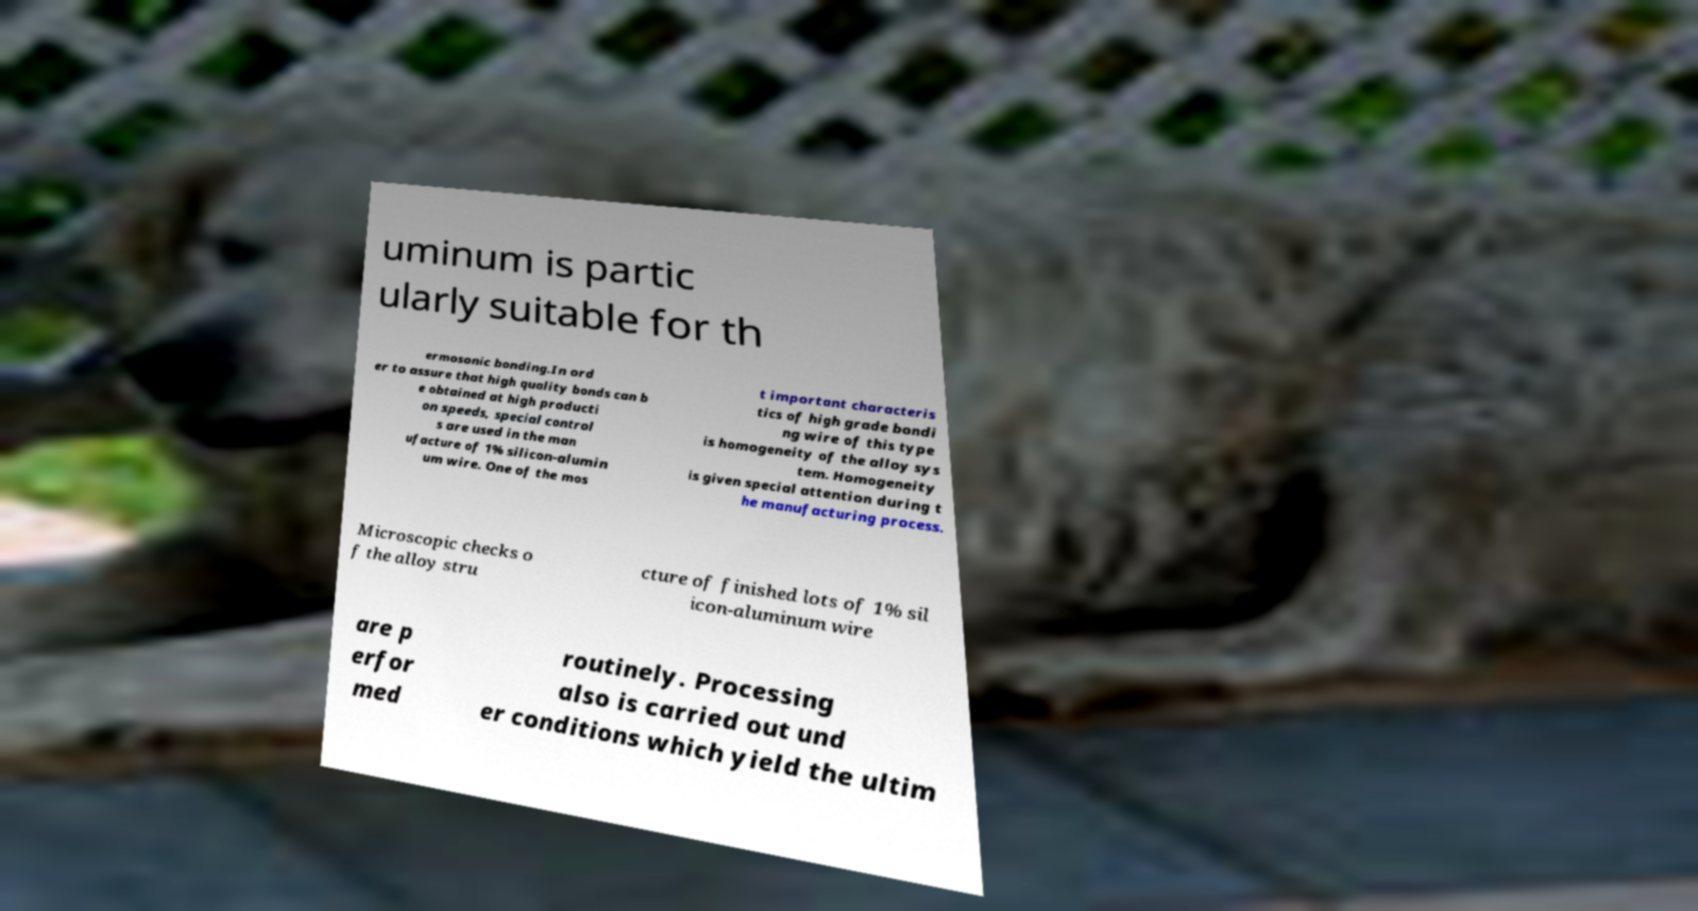What messages or text are displayed in this image? I need them in a readable, typed format. uminum is partic ularly suitable for th ermosonic bonding.In ord er to assure that high quality bonds can b e obtained at high producti on speeds, special control s are used in the man ufacture of 1% silicon-alumin um wire. One of the mos t important characteris tics of high grade bondi ng wire of this type is homogeneity of the alloy sys tem. Homogeneity is given special attention during t he manufacturing process. Microscopic checks o f the alloy stru cture of finished lots of 1% sil icon-aluminum wire are p erfor med routinely. Processing also is carried out und er conditions which yield the ultim 